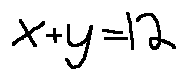Convert formula to latex. <formula><loc_0><loc_0><loc_500><loc_500>x + y = 1 2</formula> 